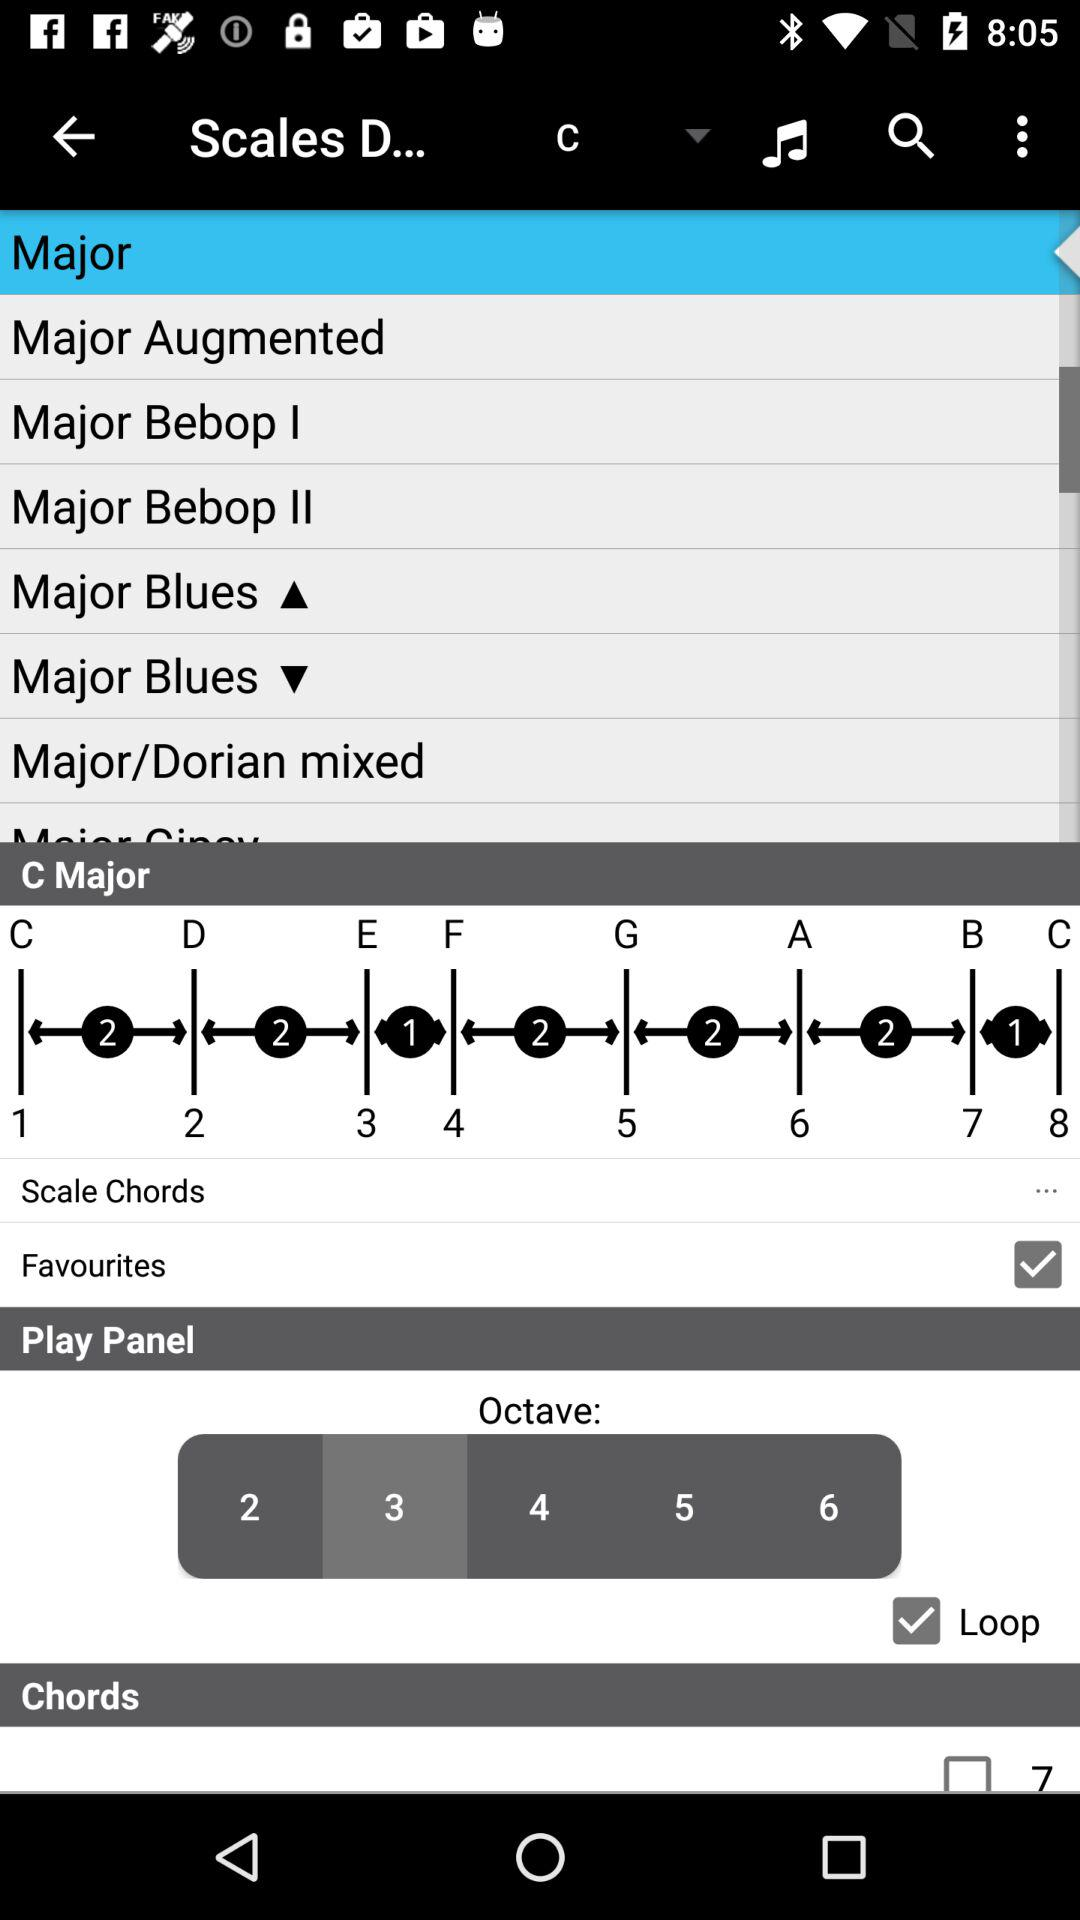Which option has been chosen in "Octave"? The option that has been chosen in "Octave" is 3. 